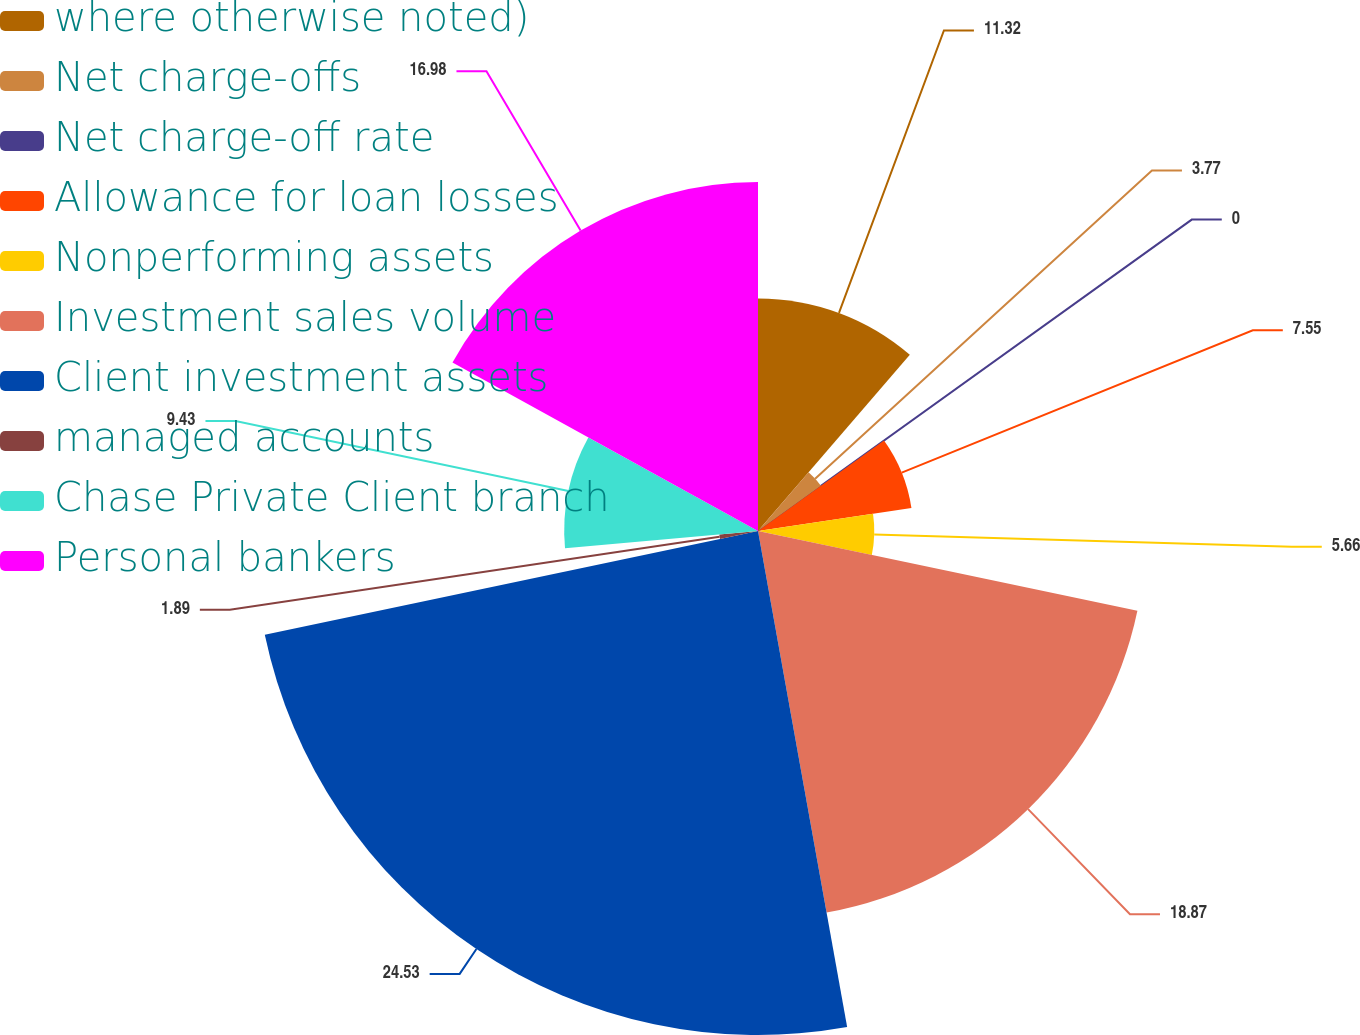Convert chart. <chart><loc_0><loc_0><loc_500><loc_500><pie_chart><fcel>where otherwise noted)<fcel>Net charge-offs<fcel>Net charge-off rate<fcel>Allowance for loan losses<fcel>Nonperforming assets<fcel>Investment sales volume<fcel>Client investment assets<fcel>managed accounts<fcel>Chase Private Client branch<fcel>Personal bankers<nl><fcel>11.32%<fcel>3.77%<fcel>0.0%<fcel>7.55%<fcel>5.66%<fcel>18.87%<fcel>24.53%<fcel>1.89%<fcel>9.43%<fcel>16.98%<nl></chart> 